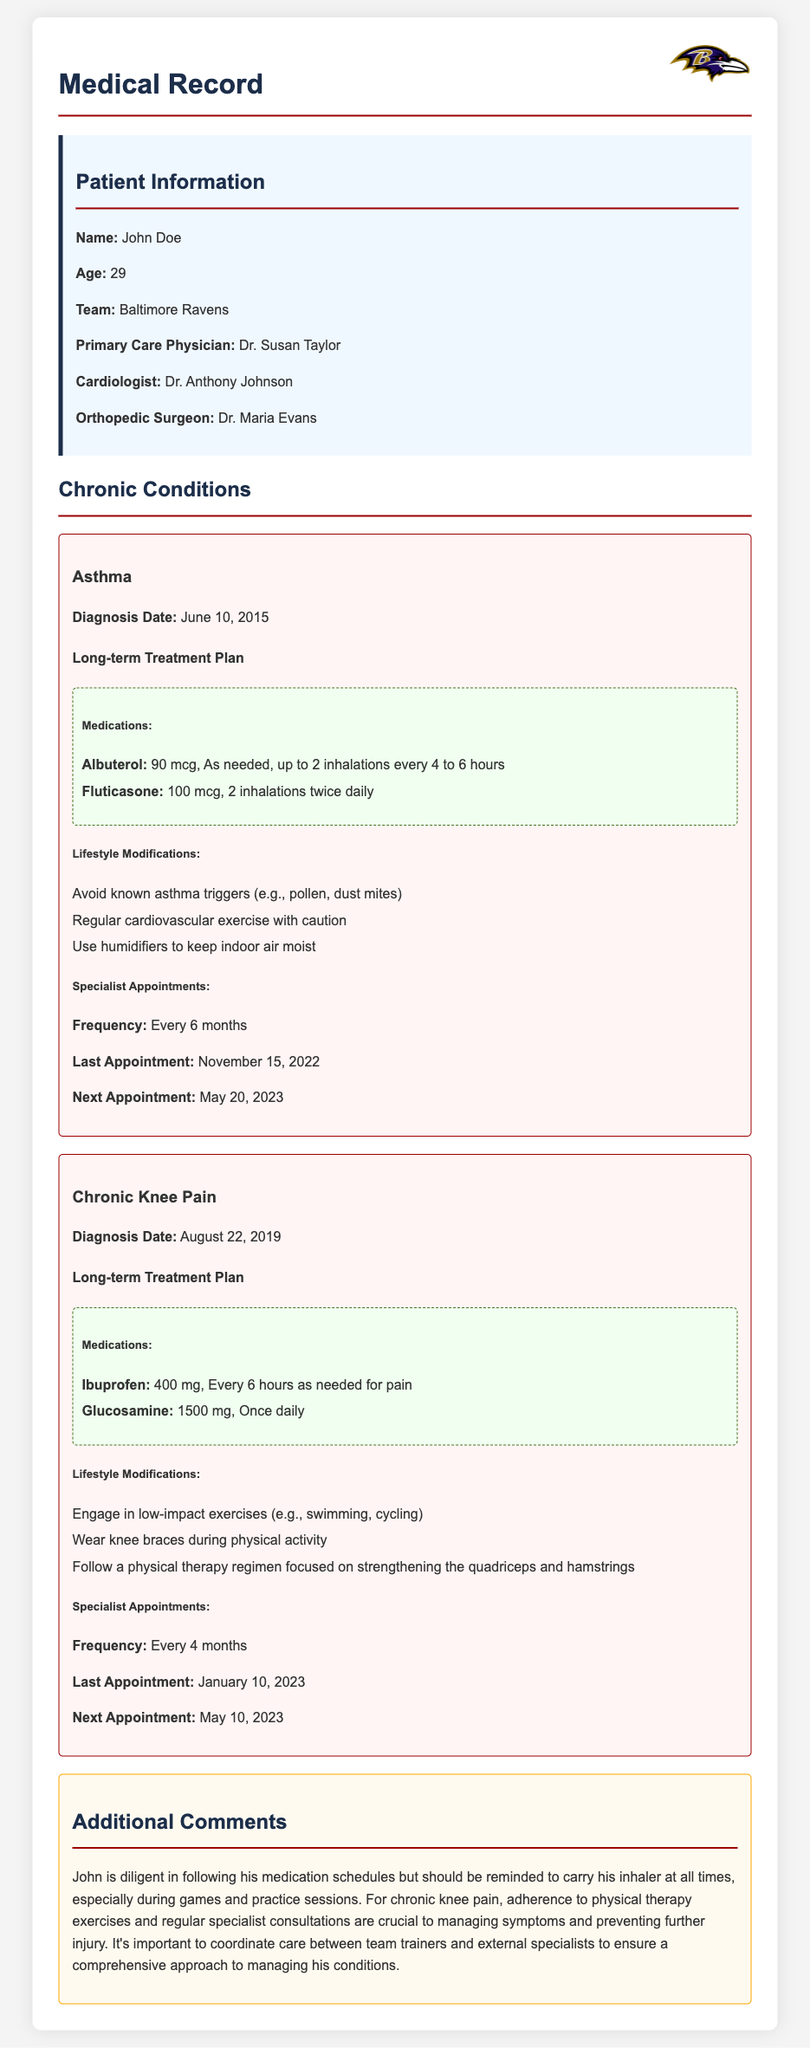What is the patient's name? The patient's name is mentioned in the patient information section of the document.
Answer: John Doe What condition was diagnosed on June 10, 2015? The diagnosis date is explicitly linked to the asthma condition in the document.
Answer: Asthma How often are specialist appointments for chronic knee pain? The frequency of specialist appointments is listed under the chronic knee pain condition in the document.
Answer: Every 4 months What medication is administered as needed for asthma? The document specifies which medications are to be taken as needed under the asthma condition.
Answer: Albuterol What lifestyle modification is suggested for managing asthma? The document outlines specific lifestyle changes to help manage asthma symptoms.
Answer: Avoid known asthma triggers What is the dosage for glucosamine? The document includes details about medication dosages under the chronic knee pain treatment plan.
Answer: 1500 mg, Once daily When was the last appointment for chronic knee pain? The last appointment is clearly stated in the specialist appointments section for chronic knee pain.
Answer: January 10, 2023 What should John be reminded to carry at all times? The additional comments section mentions a specific item that John should carry.
Answer: His inhaler Who is the primary care physician? The document provides the name of the primary care physician in the patient information section.
Answer: Dr. Susan Taylor 